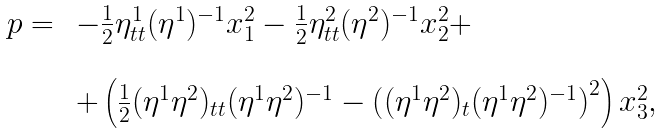Convert formula to latex. <formula><loc_0><loc_0><loc_500><loc_500>\begin{array} { l l } p = \, & - \frac { 1 } { 2 } \eta ^ { 1 } _ { t t } ( \eta ^ { 1 } ) ^ { - 1 } x _ { 1 } ^ { 2 } - \frac { 1 } { 2 } \eta ^ { 2 } _ { t t } ( \eta ^ { 2 } ) ^ { - 1 } x _ { 2 } ^ { 2 } + \\ \\ & + \left ( \frac { 1 } { 2 } ( \eta ^ { 1 } \eta ^ { 2 } ) _ { t t } ( \eta ^ { 1 } \eta ^ { 2 } ) ^ { - 1 } - \left ( ( \eta ^ { 1 } \eta ^ { 2 } ) _ { t } ( \eta ^ { 1 } \eta ^ { 2 } ) ^ { - 1 } \right ) ^ { 2 } \right ) x _ { 3 } ^ { 2 } , \end{array}</formula> 